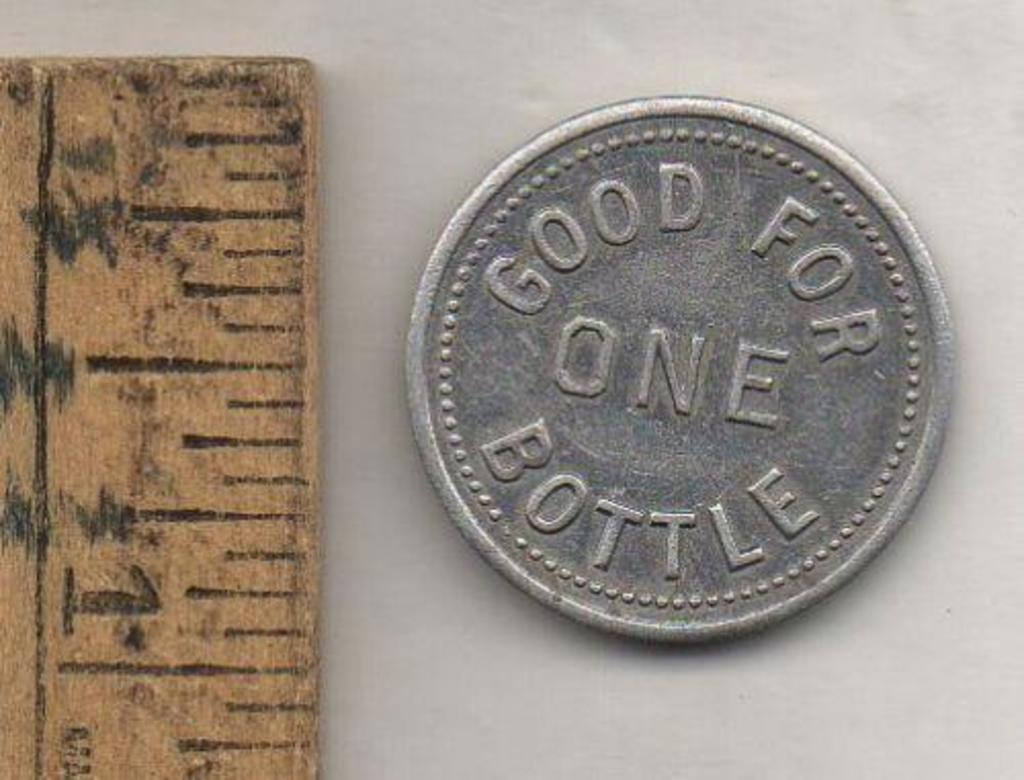<image>
Present a compact description of the photo's key features. a ruler and coin reading Good For One Bottle 